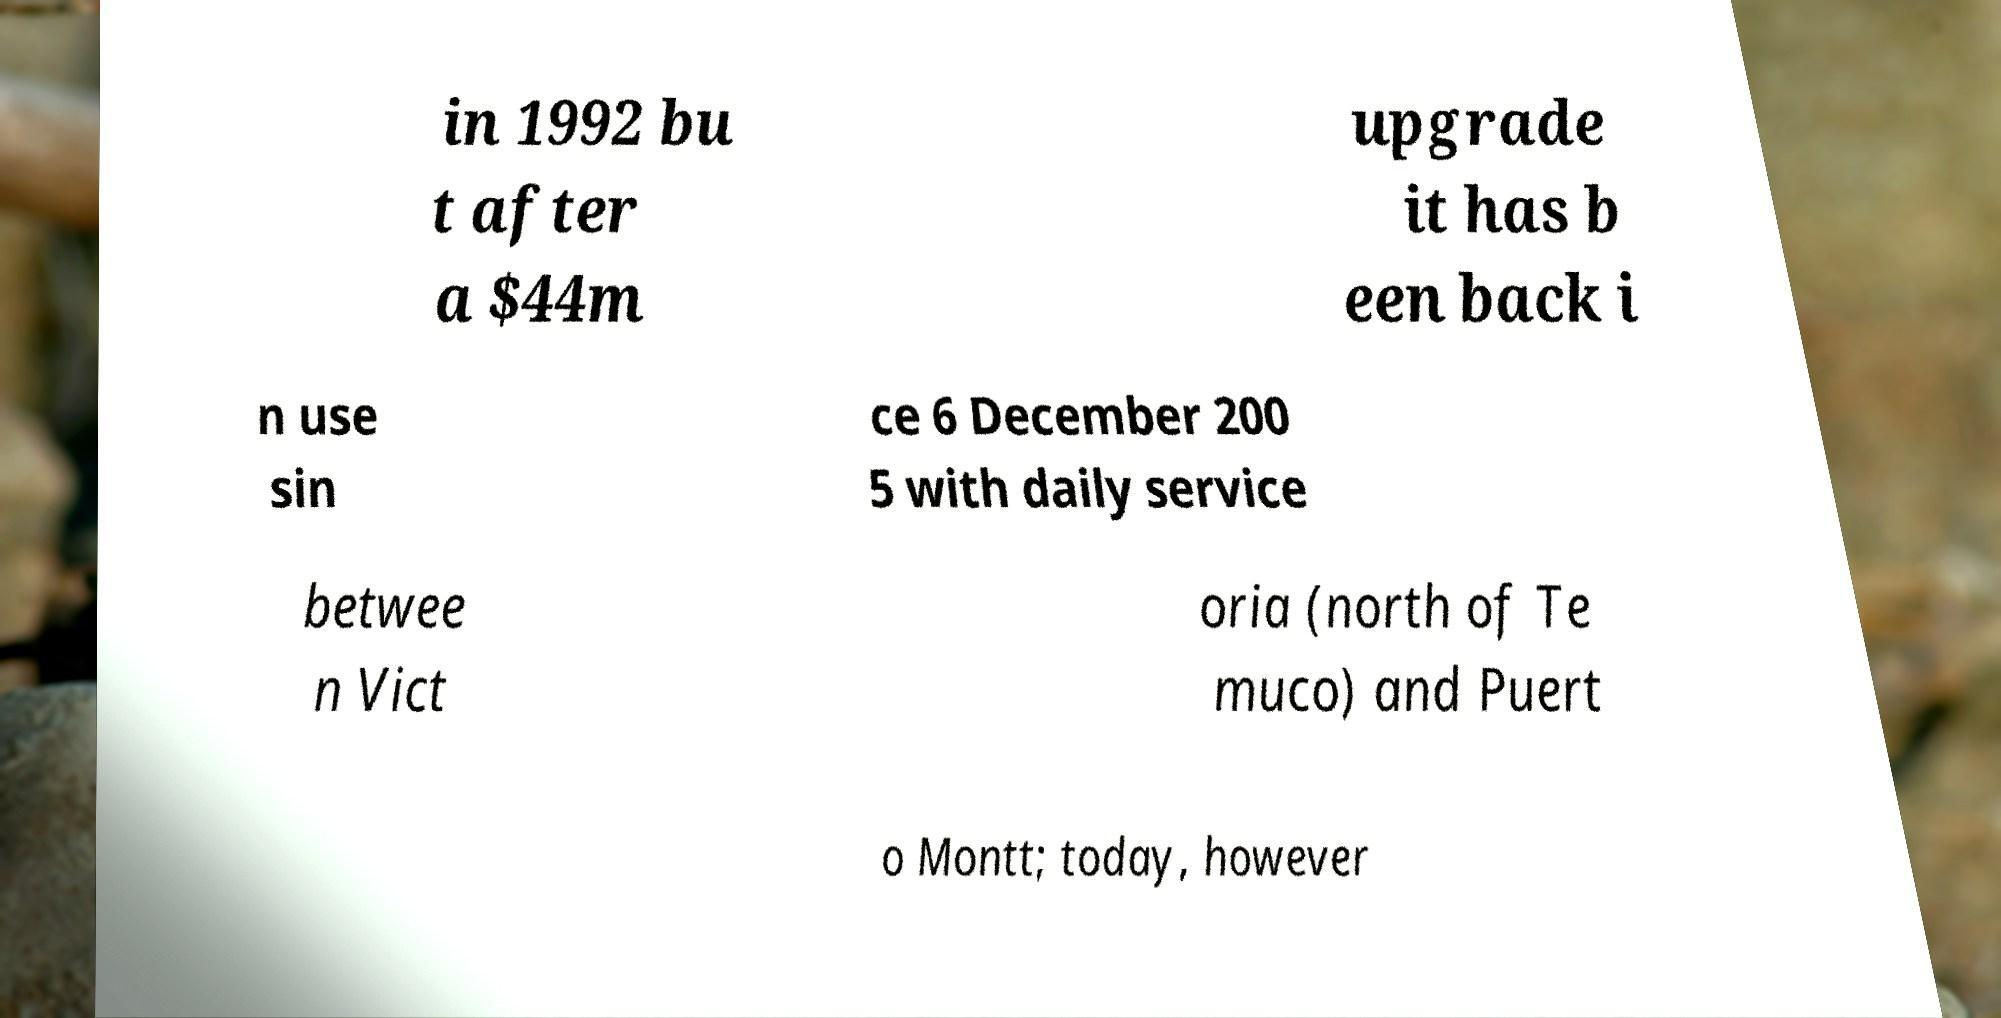Can you read and provide the text displayed in the image?This photo seems to have some interesting text. Can you extract and type it out for me? in 1992 bu t after a $44m upgrade it has b een back i n use sin ce 6 December 200 5 with daily service betwee n Vict oria (north of Te muco) and Puert o Montt; today, however 